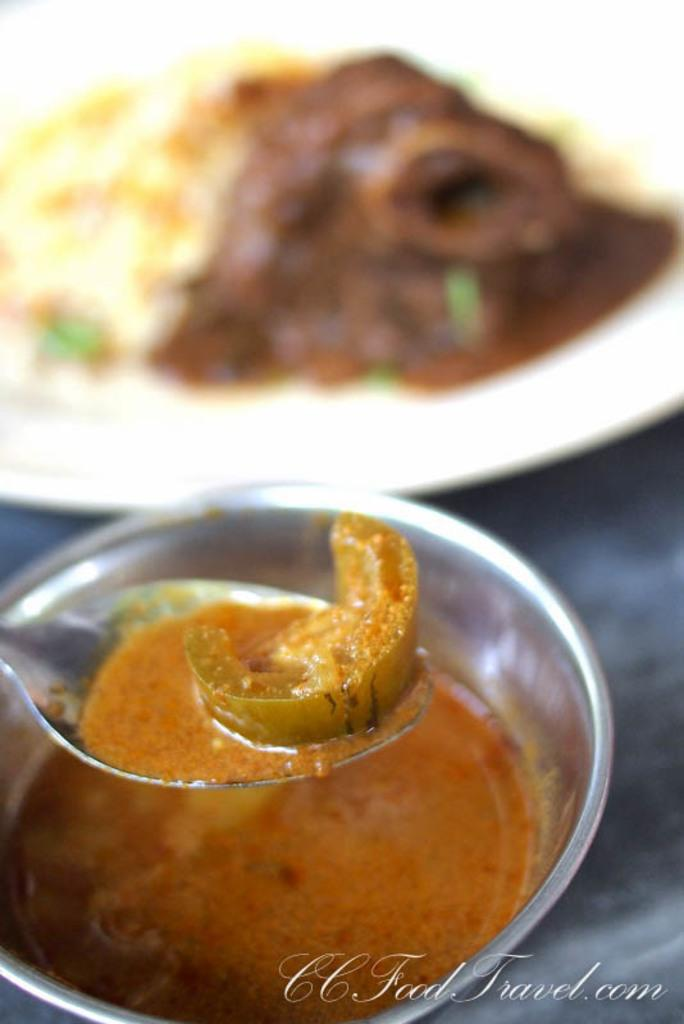What is the main subject of the image? The main subject of the image is food on a spoon in the center of the image. Can you describe any other objects related to food in the image? Yes, there is a plate and a bowl containing food in the background of the image. Is there a bee buzzing around the food on the spoon in the image? No, there is no bee present in the image. 